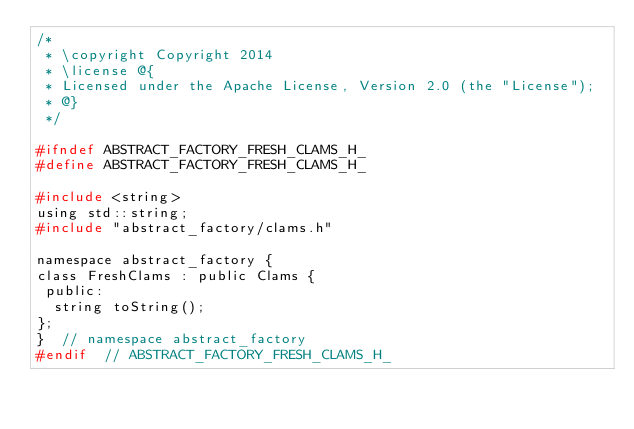<code> <loc_0><loc_0><loc_500><loc_500><_C_>/*
 * \copyright Copyright 2014
 * \license @{
 * Licensed under the Apache License, Version 2.0 (the "License");
 * @}
 */

#ifndef ABSTRACT_FACTORY_FRESH_CLAMS_H_
#define ABSTRACT_FACTORY_FRESH_CLAMS_H_

#include <string>
using std::string;
#include "abstract_factory/clams.h"

namespace abstract_factory {
class FreshClams : public Clams {
 public:
  string toString();
};
}  // namespace abstract_factory
#endif  // ABSTRACT_FACTORY_FRESH_CLAMS_H_
</code> 